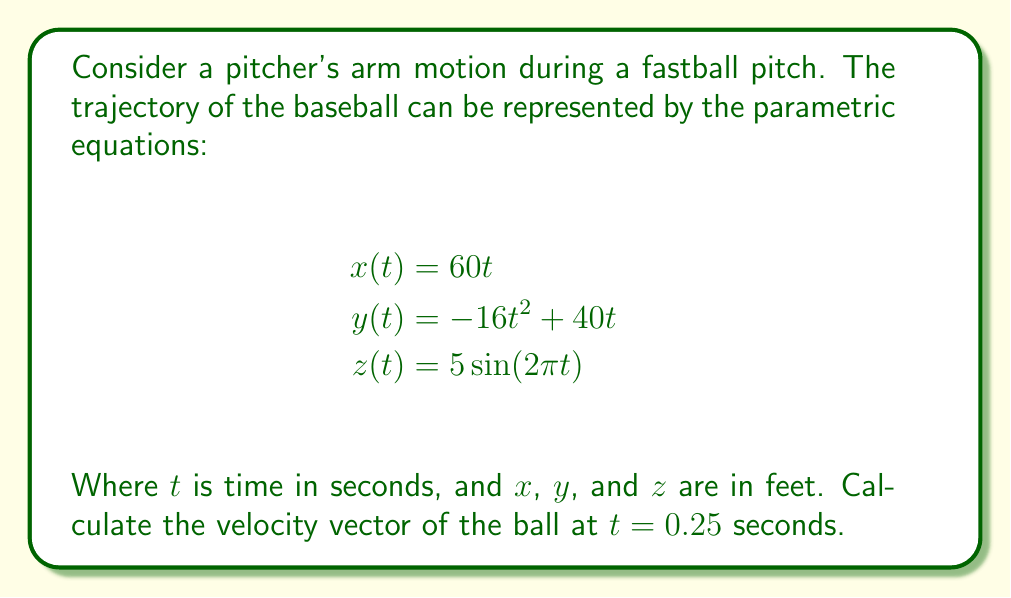Could you help me with this problem? To find the velocity vector at $t = 0.25$ seconds, we need to differentiate each component of the position vector with respect to time and then evaluate at $t = 0.25$.

1. Differentiate $x(t)$:
   $$\frac{dx}{dt} = 60$$

2. Differentiate $y(t)$:
   $$\frac{dy}{dt} = -32t + 40$$

3. Differentiate $z(t)$:
   $$\frac{dz}{dt} = 10\pi \cos(2\pi t)$$

4. The velocity vector is:
   $$\vec{v}(t) = \left(\frac{dx}{dt}, \frac{dy}{dt}, \frac{dz}{dt}\right) = (60, -32t + 40, 10\pi \cos(2\pi t))$$

5. Evaluate at $t = 0.25$:
   $$\vec{v}(0.25) = (60, -32(0.25) + 40, 10\pi \cos(2\pi(0.25)))$$
   $$= (60, 32, 10\pi \cos(\frac{\pi}{2}))$$
   $$= (60, 32, 0)$$

Therefore, the velocity vector at $t = 0.25$ seconds is $(60, 32, 0)$ feet per second.
Answer: $(60, 32, 0)$ ft/s 